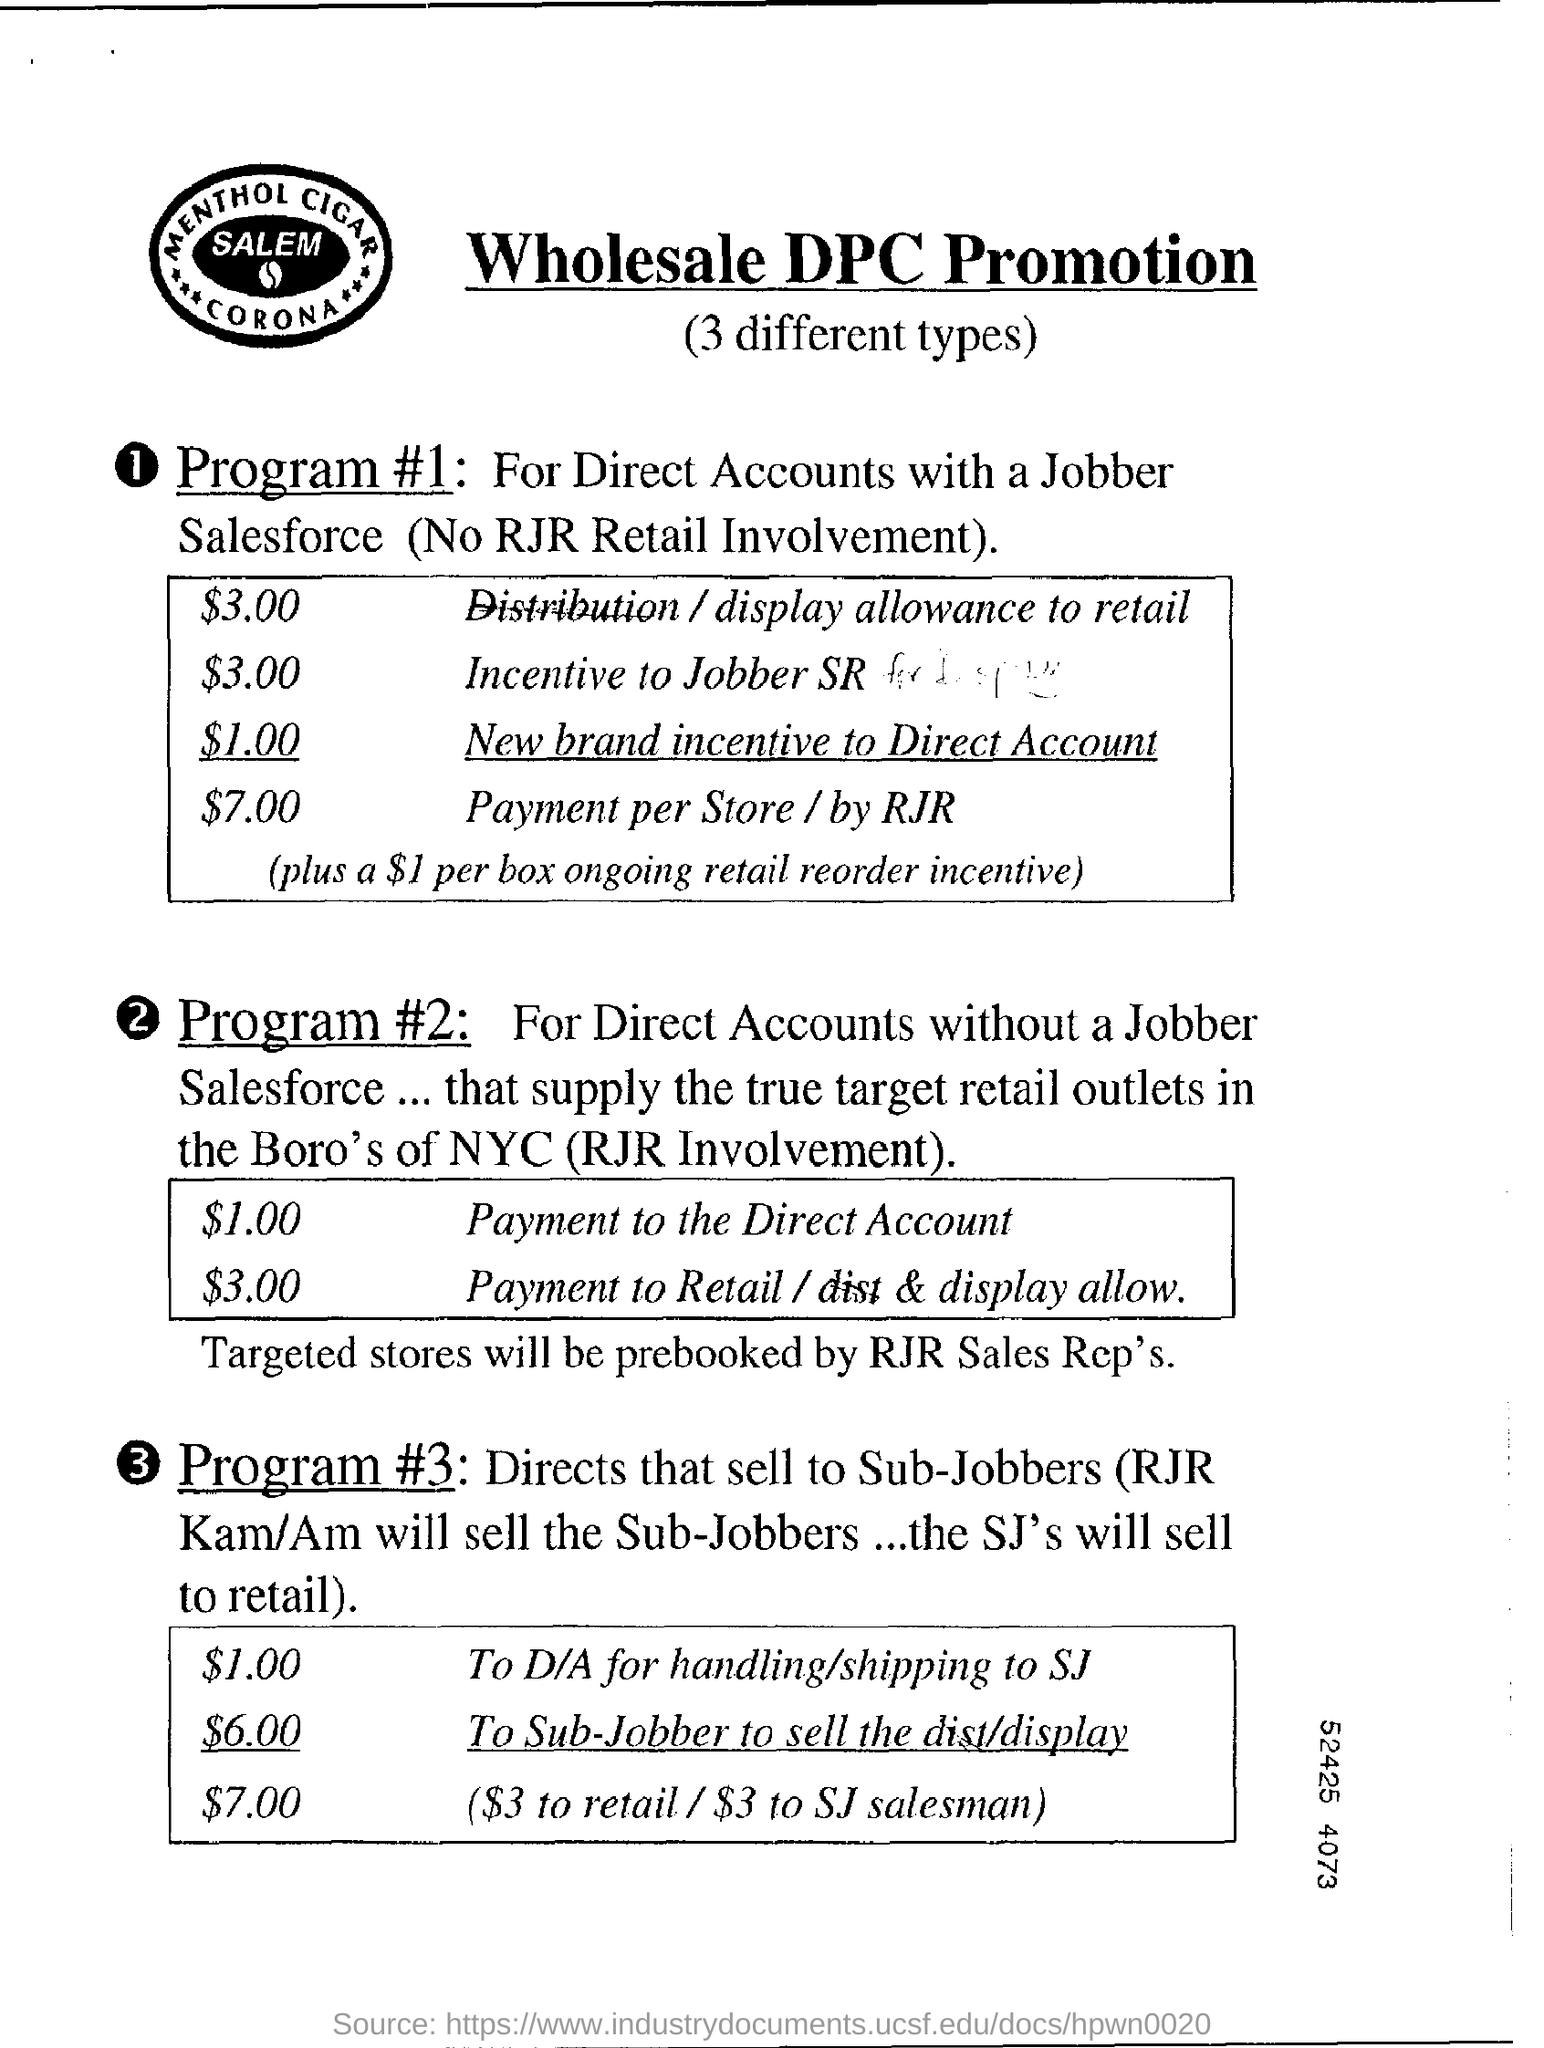What is the Title of the document?
Ensure brevity in your answer.  Wholesale DPC Promotion. What is the Display allowance to retail?
Your answer should be compact. $3.00. What is the incentive to jobber SR?
Provide a short and direct response. $3.00. What is the new brand incentive to direct account?
Make the answer very short. $1.00. What is the Payment per store / by RJR?
Provide a short and direct response. $7.00. What is the cost to D/A for handling/shipping to SJ?
Give a very brief answer. $1.00. What is the cost to Sub-Jobber to sell the display?
Your answer should be very brief. $6.00. 